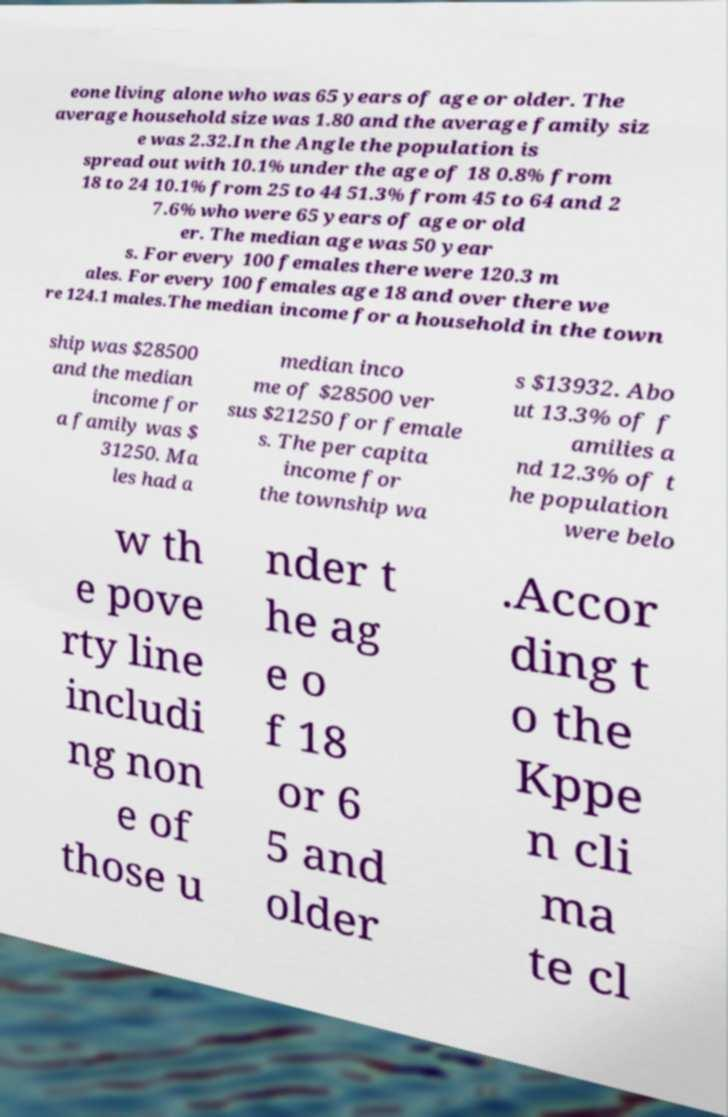Could you extract and type out the text from this image? eone living alone who was 65 years of age or older. The average household size was 1.80 and the average family siz e was 2.32.In the Angle the population is spread out with 10.1% under the age of 18 0.8% from 18 to 24 10.1% from 25 to 44 51.3% from 45 to 64 and 2 7.6% who were 65 years of age or old er. The median age was 50 year s. For every 100 females there were 120.3 m ales. For every 100 females age 18 and over there we re 124.1 males.The median income for a household in the town ship was $28500 and the median income for a family was $ 31250. Ma les had a median inco me of $28500 ver sus $21250 for female s. The per capita income for the township wa s $13932. Abo ut 13.3% of f amilies a nd 12.3% of t he population were belo w th e pove rty line includi ng non e of those u nder t he ag e o f 18 or 6 5 and older .Accor ding t o the Kppe n cli ma te cl 